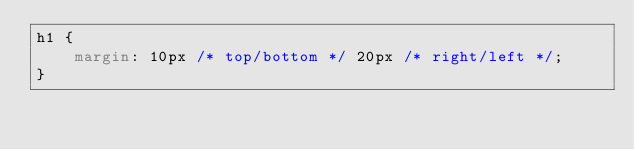Convert code to text. <code><loc_0><loc_0><loc_500><loc_500><_CSS_>h1 {
    margin: 10px /* top/bottom */ 20px /* right/left */;
}
</code> 